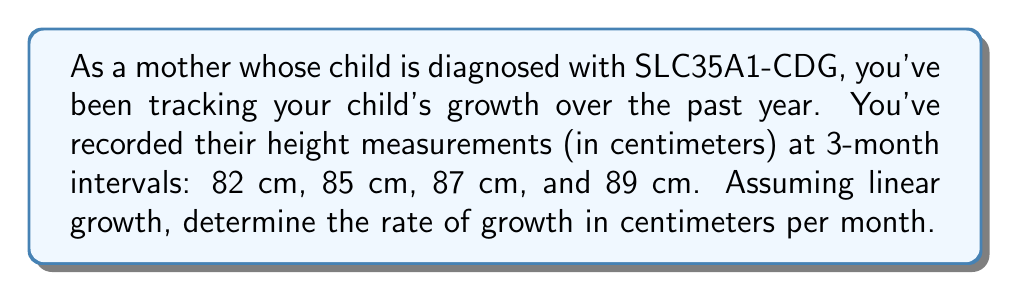Can you answer this question? To solve this problem, we'll follow these steps:

1) First, let's identify the total growth over the year:
   $\text{Total growth} = 89 \text{ cm} - 82 \text{ cm} = 7 \text{ cm}$

2) We need to determine the rate of growth per month. Since we have data for a full year, we can divide the total growth by 12 months:

   $$\text{Rate of growth} = \frac{\text{Total growth}}{\text{Number of months}}$$

   $$\text{Rate of growth} = \frac{7 \text{ cm}}{12 \text{ months}}$$

3) Simplify the fraction:
   
   $$\text{Rate of growth} = \frac{7}{12} \text{ cm/month}$$

4) To express this as a decimal, divide 7 by 12:
   
   $$\text{Rate of growth} \approx 0.5833 \text{ cm/month}$$

This rate indicates that, on average, the child is growing about 0.5833 cm each month, which is consistent with the linear growth assumption given in the problem.

Note: In reality, growth rates for children with SLC35A1-CDG may not be linear and could vary significantly. Regular monitoring and consultation with healthcare providers are crucial for children with this condition.
Answer: The rate of growth is $\frac{7}{12}$ cm/month or approximately 0.5833 cm/month. 